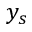Convert formula to latex. <formula><loc_0><loc_0><loc_500><loc_500>y _ { s }</formula> 